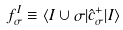Convert formula to latex. <formula><loc_0><loc_0><loc_500><loc_500>f _ { \sigma } ^ { I } \equiv \langle I \cup \sigma | \hat { c } _ { \sigma } ^ { + } | I \rangle \,</formula> 